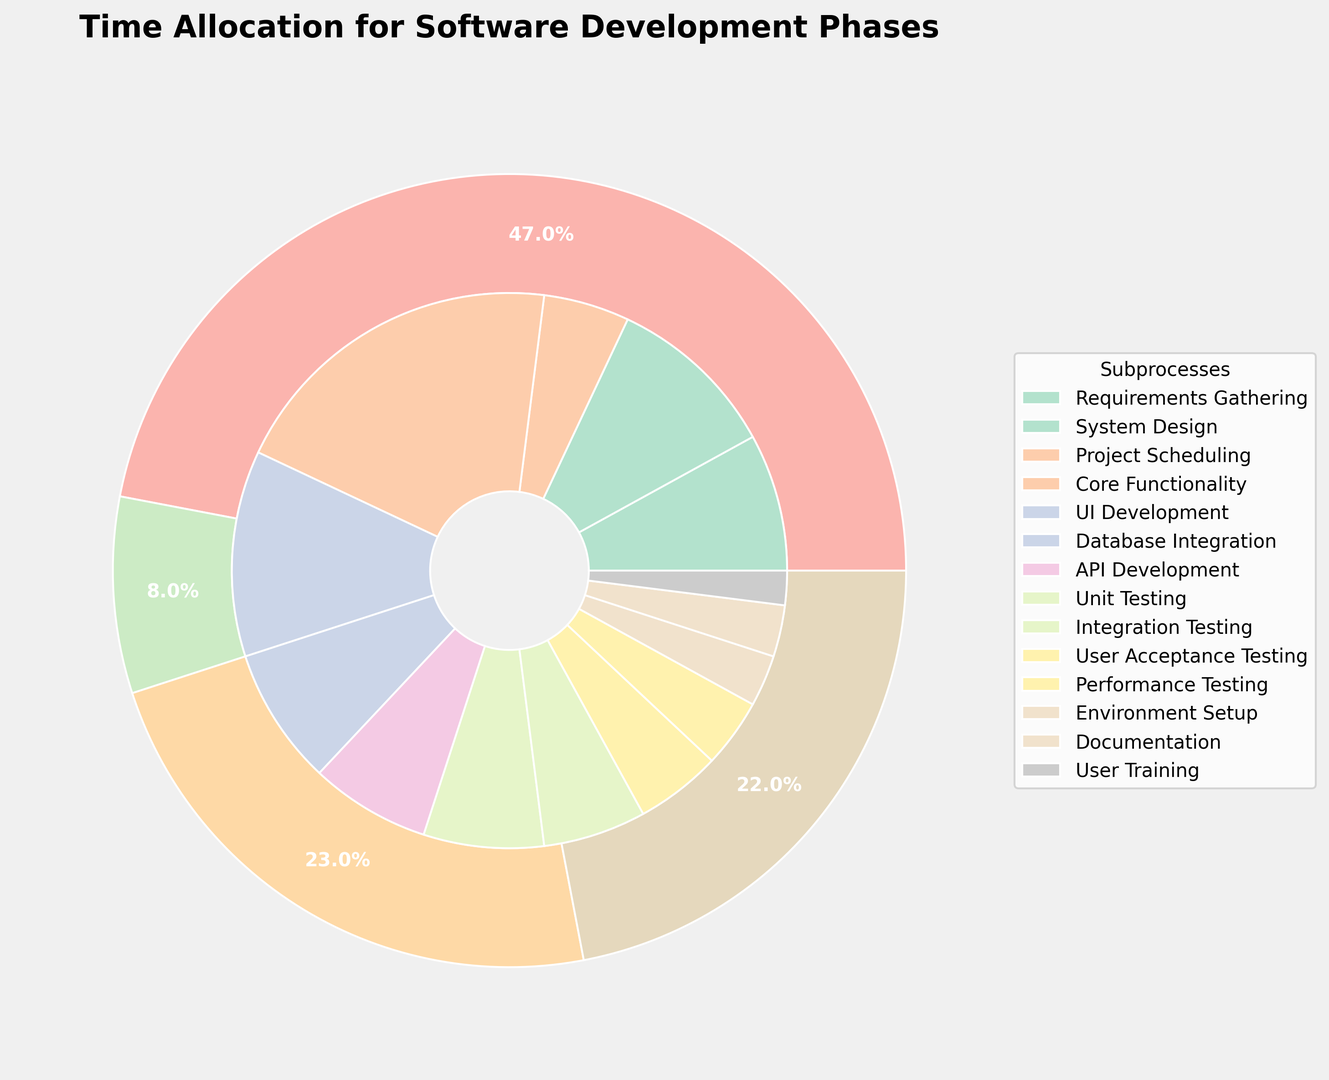How much total time is allocated to the planning phase? The outer pie chart indicates different phases of software development. By looking at the portion of the pie labeled "Planning," we can determine that the sum of time allocated to this phase is the sum of all its subprocesses: 8% (Requirements Gathering) + 10% (System Design) + 5% (Project Scheduling) = 23%.
Answer: 23% Which subprocess in the coding phase takes up the most time? In the inner pie chart, we can find segments corresponding to each subprocess within the coding phase. The largest segment within coding is labeled "Core Functionality" at 20%.
Answer: Core Functionality Compare the total time allocated to testing and deployment phases; which one is higher and by how much? The outer pie chart shows the total time percentage for each phase. Summing the percentages for testing subprocesses (7%+6%+5%+4% = 22%) and deployment subprocesses (3%+3%+2% = 8%), we find testing has a higher total time. The difference is 22% - 8% = 14%.
Answer: Testing by 14% What is the time percentage difference between Unit Testing and User Training? From the inner pie chart, Unit Testing is allocated 7%, while User Training is allocated 2%. The difference in their percentage allocation is 7% - 2% = 5%.
Answer: 5% Determine the total time allocated to API Development and Documentation. We need to locate the segments for both API Development and Documentation in the inner pie chart. API Development is 7%, and Documentation is 3%. Summing them gives 7% + 3% = 10%.
Answer: 10% How much time is allocated to subprocesses involving Testing, and how does it compare to the coding phase? Summing each subprocess within the Testing phase (Unit Testing, Integration Testing, User Acceptance Testing, Performance Testing) results in 7% + 6% + 5% + 4% = 22%. For the Coding phase, the sum is 20% (Core Functionality) + 12% (UI Development) + 8% (Database Integration) + 7% (API Development) = 47%. Coding has more time allocated (47%) compared to Testing (22%); the difference is 47% - 22% = 25%.
Answer: Coding by 25% Which phase has the smallest workload and what is its percentage? Observing the outer pie chart, we find the phase with the smallest portion. Deployment, being the smallest segment, has a total percentage of 8%.
Answer: Deployment, 8% Which subprocess is represented with a greenish color in the inner pie chart? By examining the color scheme in the inner pie chart and matching it to the legend, the greenish segment corresponds to "Core Functionality."
Answer: Core Functionality 